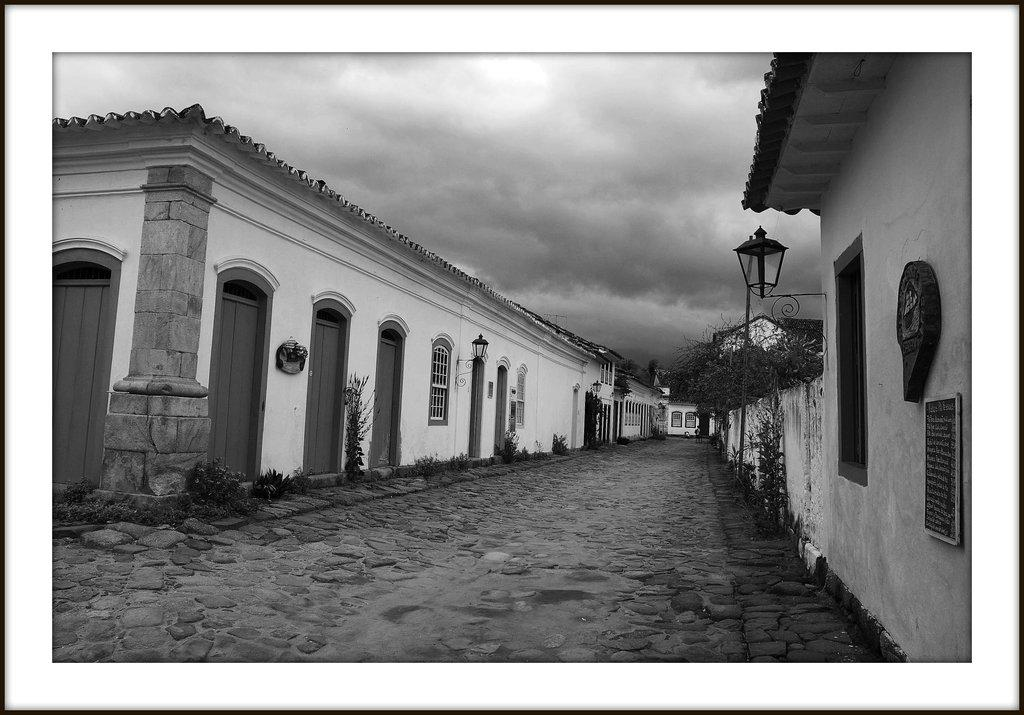What type of structures are present in the image? There are buildings in the image. What can be seen on the walls of the buildings? There are lights on the walls of the buildings. What type of vegetation is present in the image? There are plants in the image. What else can be found on the ground in the image? There are other objects on the ground. What is visible in the background of the image? The sky is visible in the background of the image. How is the image presented in terms of color? The image is black and white in color. What type of bubble can be seen floating near the buildings in the image? There is no bubble present in the image; it is a black and white image with no visible bubbles. What is the rod used for in the image? There is no rod present in the image, so it cannot be used for anything. 